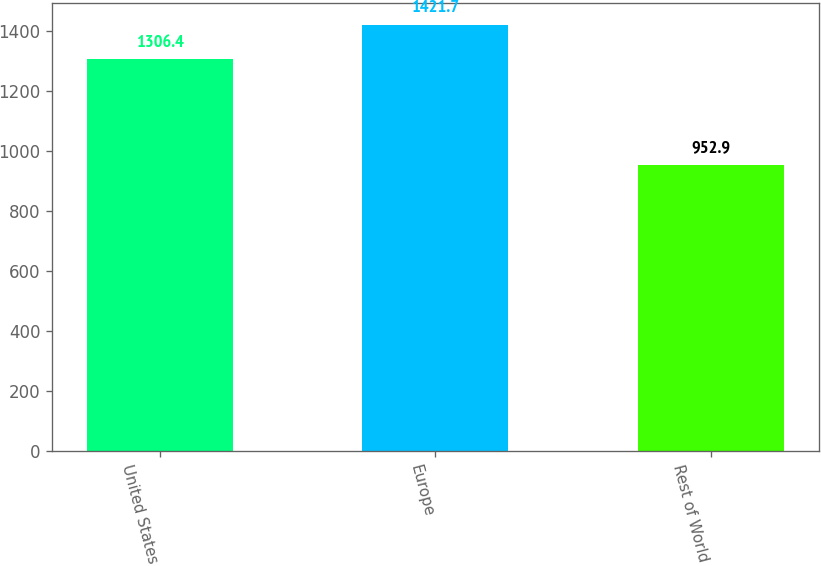Convert chart to OTSL. <chart><loc_0><loc_0><loc_500><loc_500><bar_chart><fcel>United States<fcel>Europe<fcel>Rest of World<nl><fcel>1306.4<fcel>1421.7<fcel>952.9<nl></chart> 